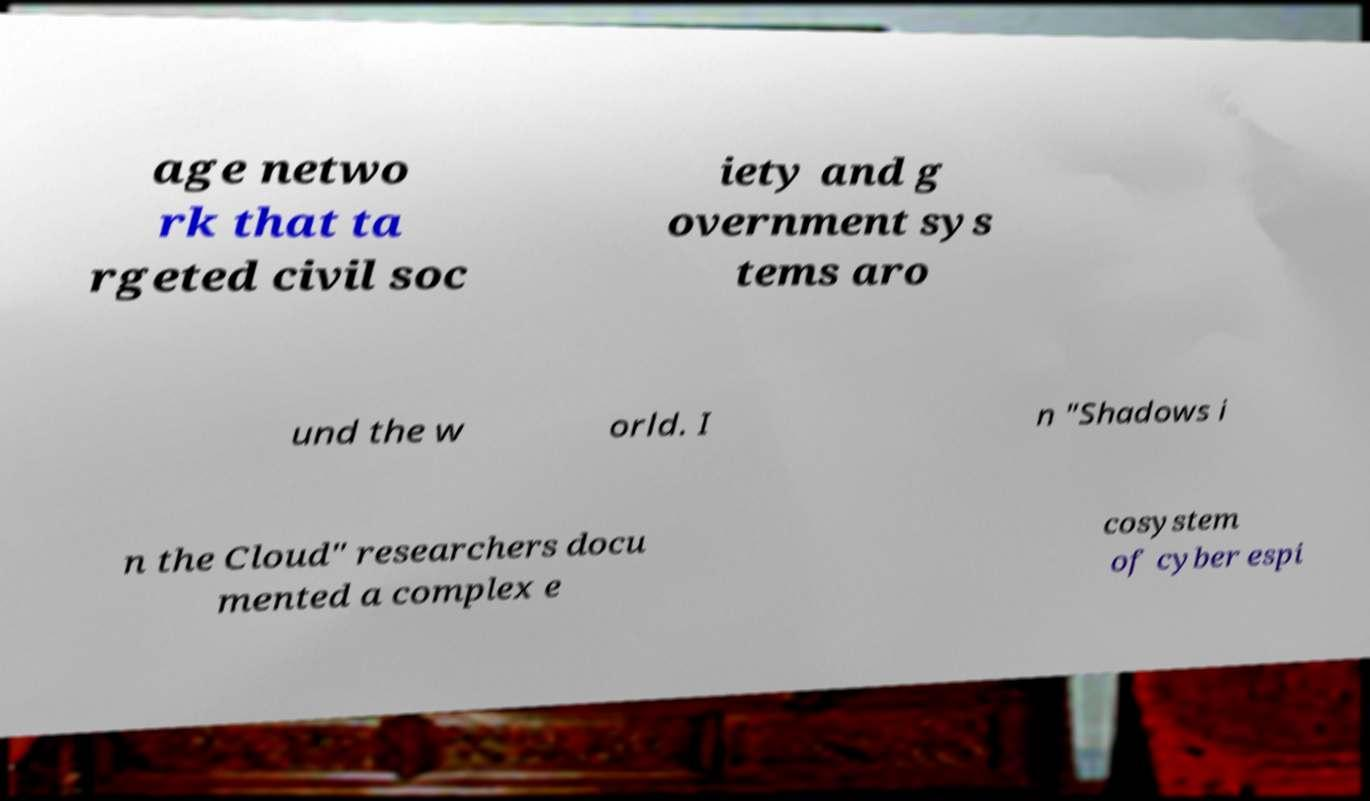Could you assist in decoding the text presented in this image and type it out clearly? age netwo rk that ta rgeted civil soc iety and g overnment sys tems aro und the w orld. I n "Shadows i n the Cloud" researchers docu mented a complex e cosystem of cyber espi 